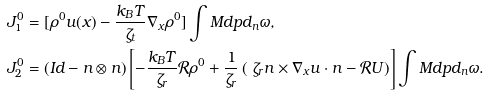<formula> <loc_0><loc_0><loc_500><loc_500>J _ { 1 } ^ { 0 } & = [ \rho ^ { 0 } u ( x ) - \frac { k _ { B } T } { \zeta _ { t } } \nabla _ { x } \rho ^ { 0 } ] \int M d p d _ { n } \omega , \\ J _ { 2 } ^ { 0 } & = ( I d - n \otimes n ) \left [ - \frac { k _ { B } T } { \zeta _ { r } } \mathcal { R } \rho ^ { 0 } + \frac { 1 } { \zeta _ { r } } \left ( \ \zeta _ { r } n \times \nabla _ { x } u \cdot n - \mathcal { R } U \right ) \right ] \int M d p d _ { n } \omega .</formula> 